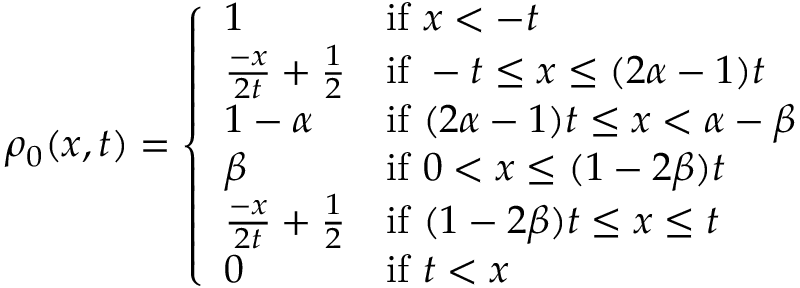Convert formula to latex. <formula><loc_0><loc_0><loc_500><loc_500>\rho _ { 0 } ( x , t ) = \left \{ \begin{array} { l l } { 1 } & { i f x < - t } \\ { \frac { - x } { 2 t } + \frac { 1 } { 2 } } & { i f - t \leq x \leq ( 2 \alpha - 1 ) t } \\ { 1 - \alpha } & { i f ( 2 \alpha - 1 ) t \leq x < \alpha - \beta } \\ { \beta } & { i f 0 < x \leq ( 1 - 2 \beta ) t } \\ { \frac { - x } { 2 t } + \frac { 1 } { 2 } } & { i f ( 1 - 2 \beta ) t \leq x \leq t } \\ { 0 } & { i f t < x } \end{array}</formula> 